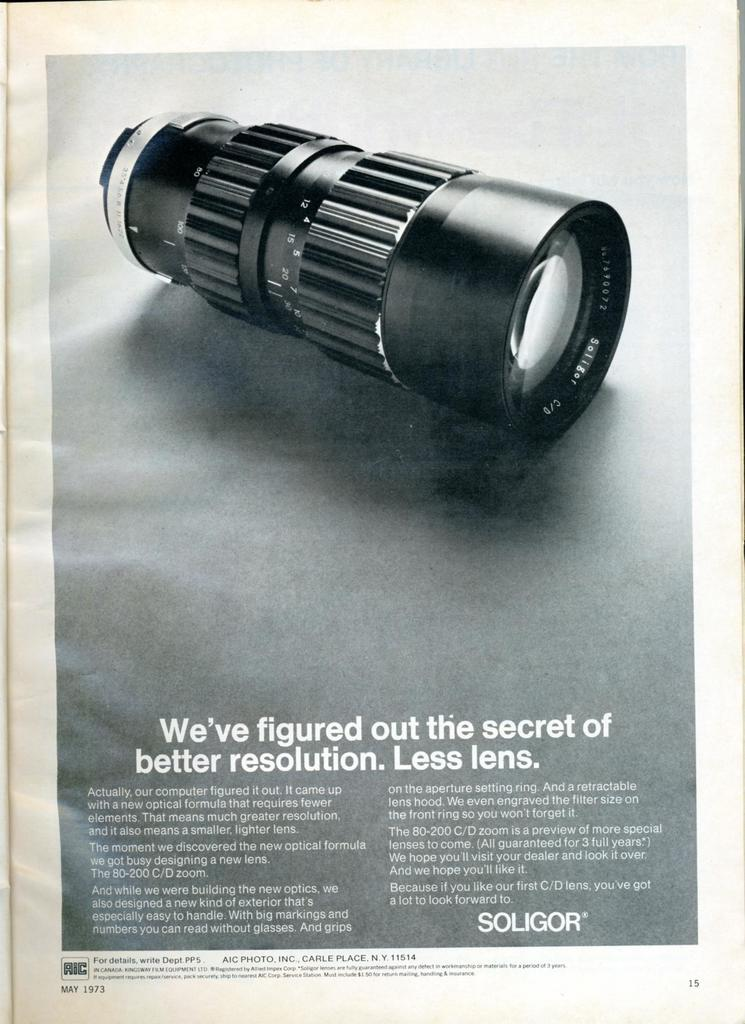What is featured in the image? There is a poster in the image. What can be found on the poster? The poster contains text and a picture of a camera. What type of discussion is taking place in the image? There is no discussion taking place in the image; it only features a poster with text and a picture of a camera. 